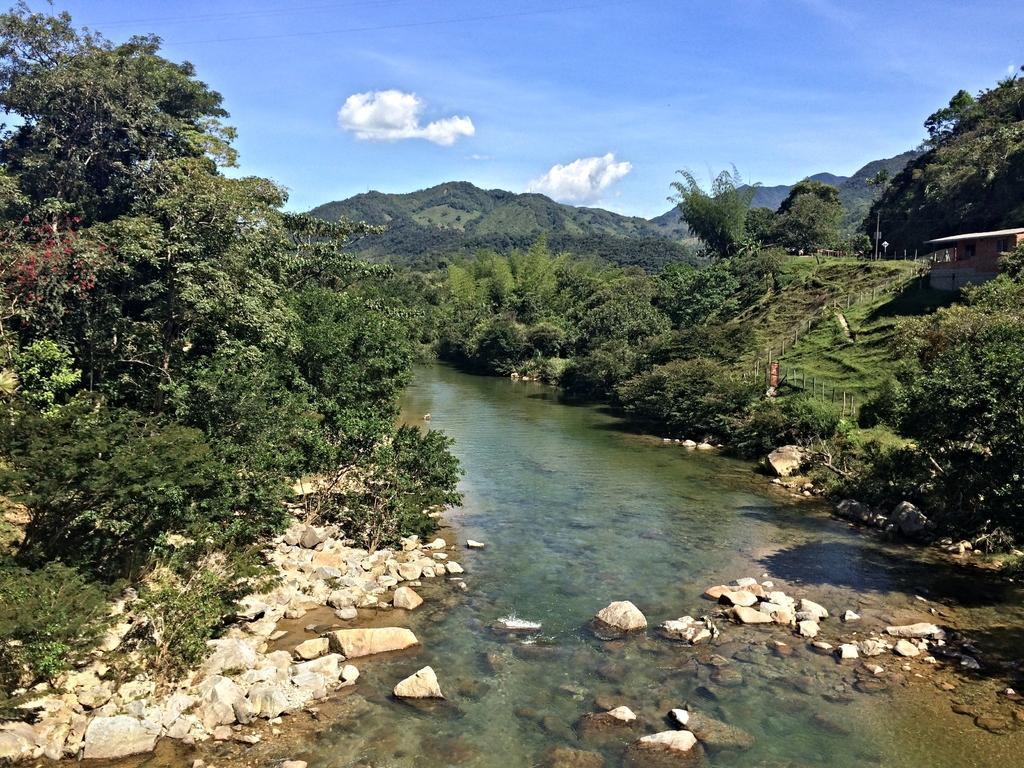Describe this image in one or two sentences. In this image I can see small stones and water. Both-side I can see trees and fencing. Back Side I can see mountains. We can see house and sign boards. The sky is in blue and white color. 